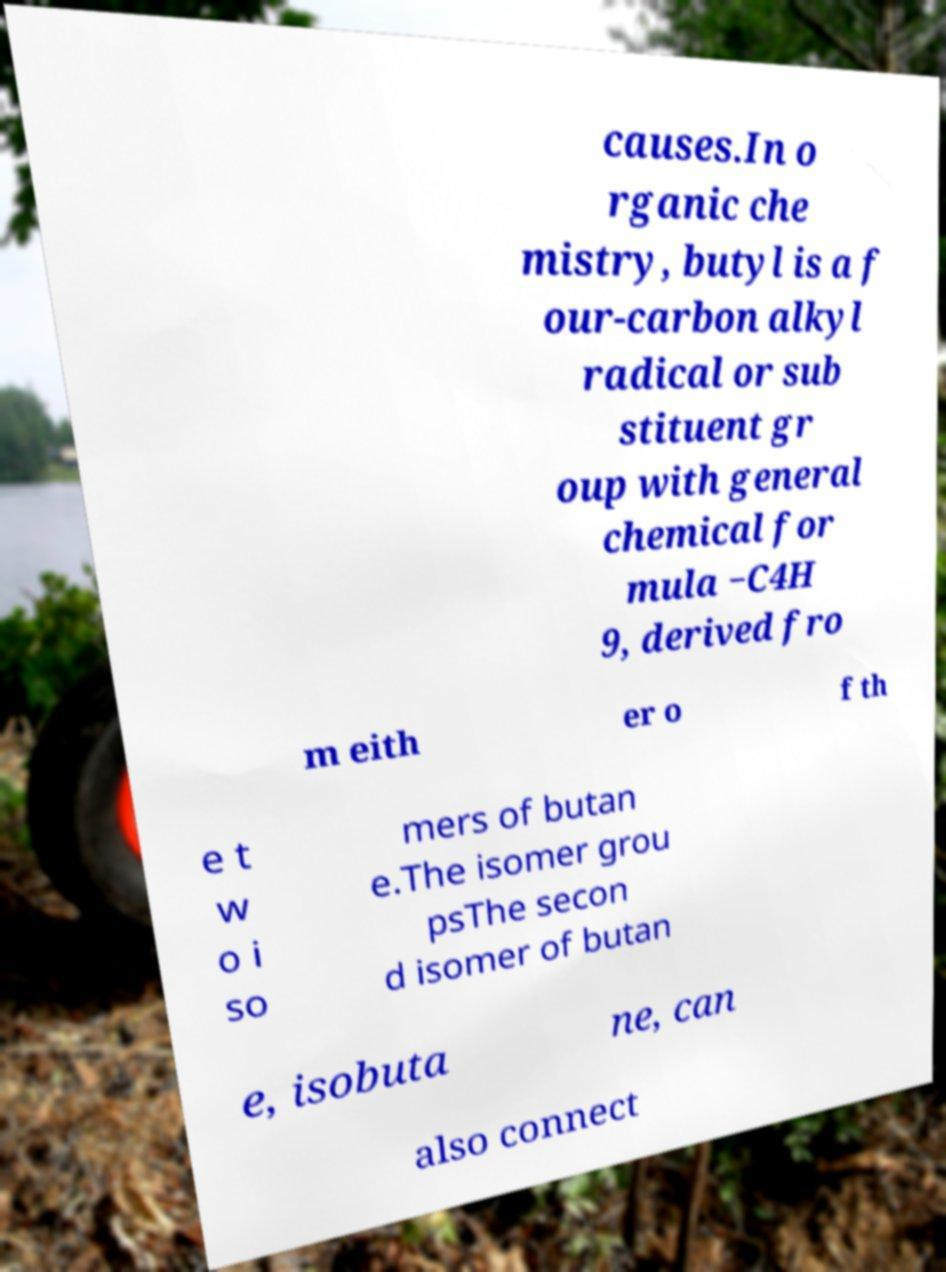There's text embedded in this image that I need extracted. Can you transcribe it verbatim? causes.In o rganic che mistry, butyl is a f our-carbon alkyl radical or sub stituent gr oup with general chemical for mula −C4H 9, derived fro m eith er o f th e t w o i so mers of butan e.The isomer grou psThe secon d isomer of butan e, isobuta ne, can also connect 